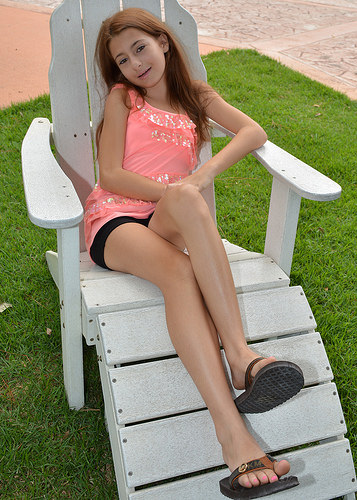<image>
Is the girl on the grass? Yes. Looking at the image, I can see the girl is positioned on top of the grass, with the grass providing support. Is the human on the grass? No. The human is not positioned on the grass. They may be near each other, but the human is not supported by or resting on top of the grass. Is the girl on the grass? No. The girl is not positioned on the grass. They may be near each other, but the girl is not supported by or resting on top of the grass. Is the grass under the chair? Yes. The grass is positioned underneath the chair, with the chair above it in the vertical space. 